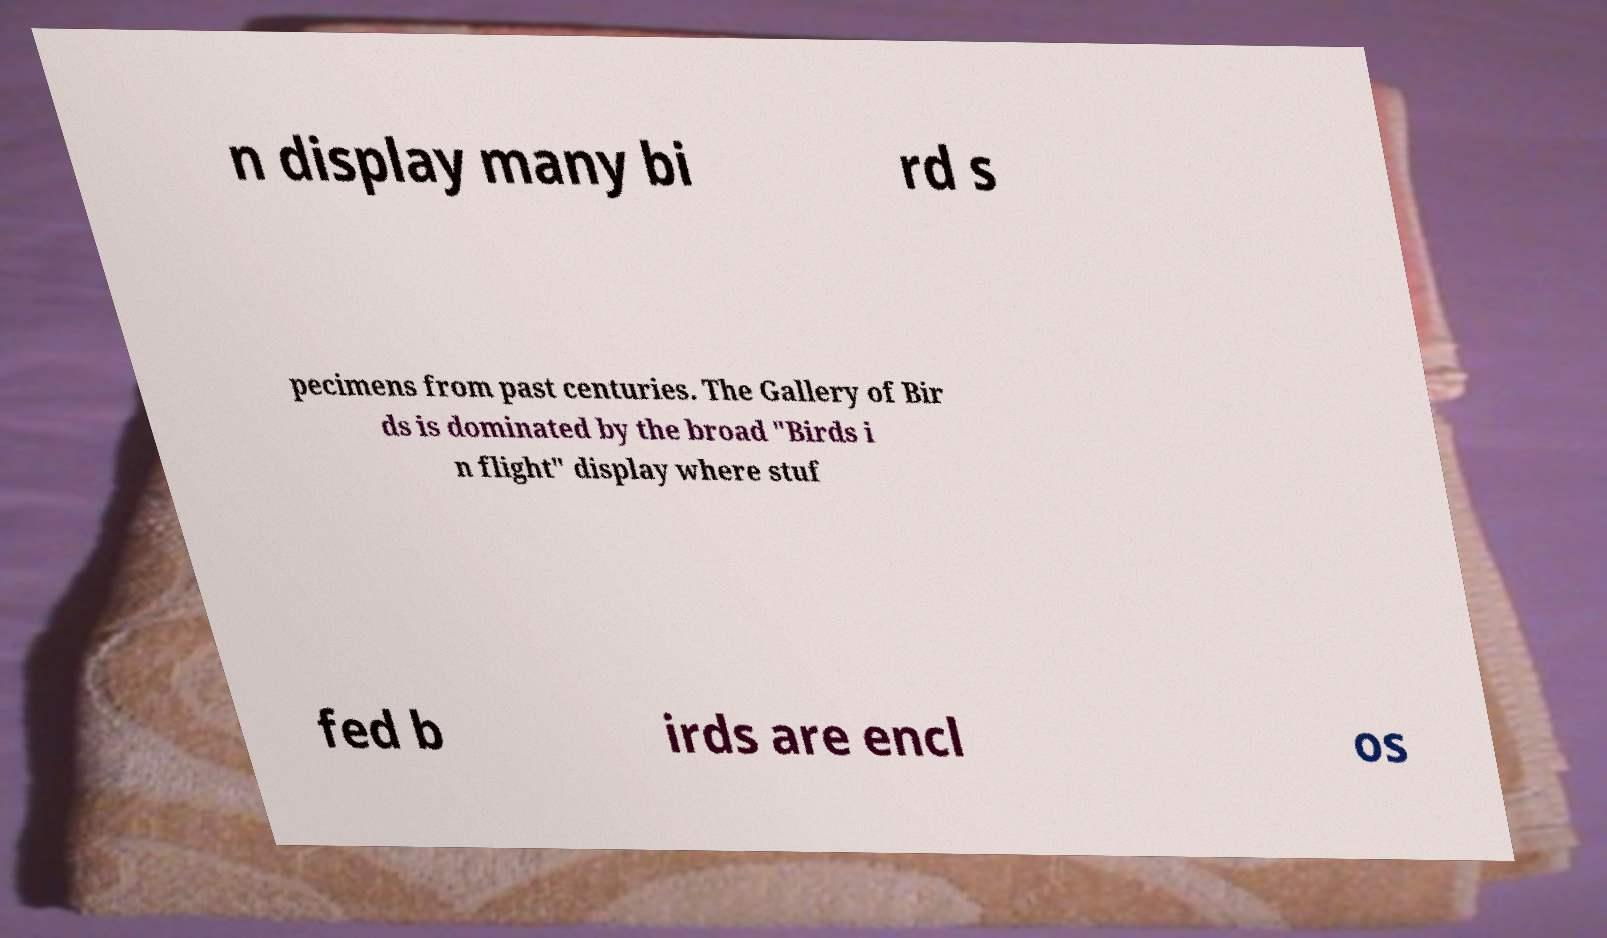What messages or text are displayed in this image? I need them in a readable, typed format. n display many bi rd s pecimens from past centuries. The Gallery of Bir ds is dominated by the broad "Birds i n flight" display where stuf fed b irds are encl os 